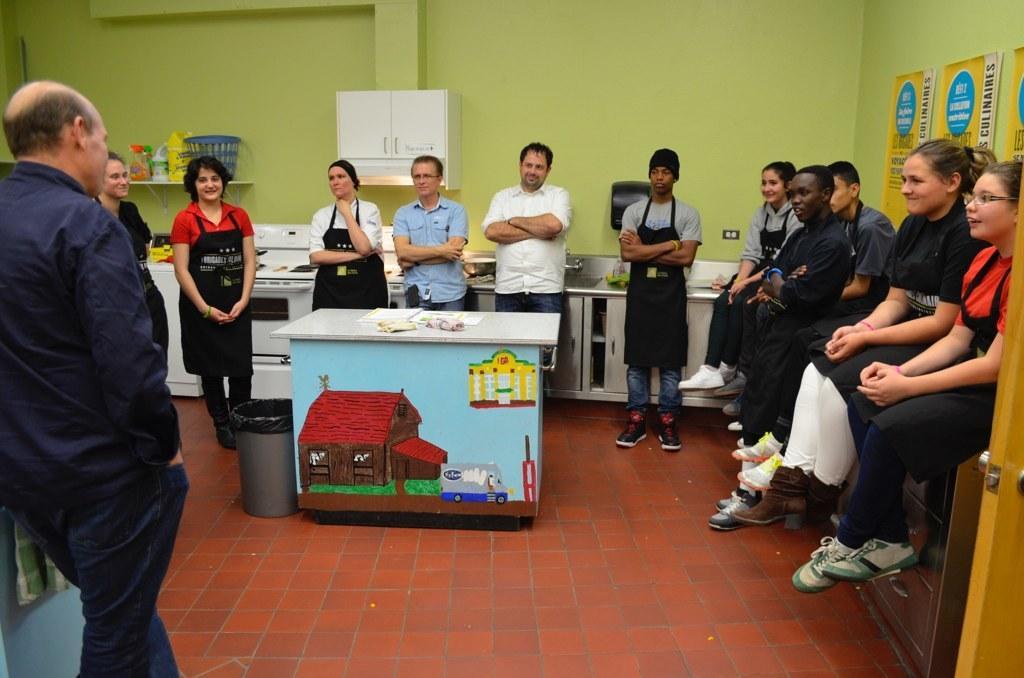Please provide a concise description of this image. In this image we can see people and few of them are sitting on the platform. Here we can see a table, bin, oven, stove, basket, bottles, cupboards, boards, and few objects. In the background we can see wall. 